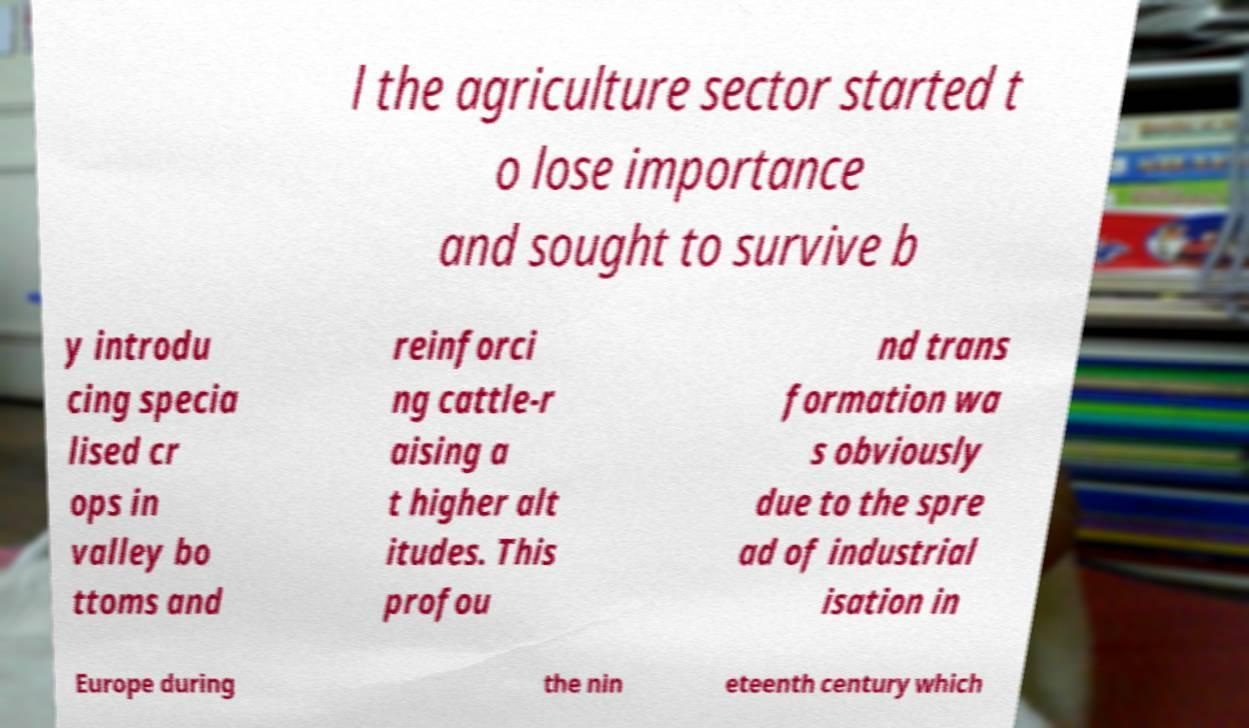Could you assist in decoding the text presented in this image and type it out clearly? l the agriculture sector started t o lose importance and sought to survive b y introdu cing specia lised cr ops in valley bo ttoms and reinforci ng cattle-r aising a t higher alt itudes. This profou nd trans formation wa s obviously due to the spre ad of industrial isation in Europe during the nin eteenth century which 